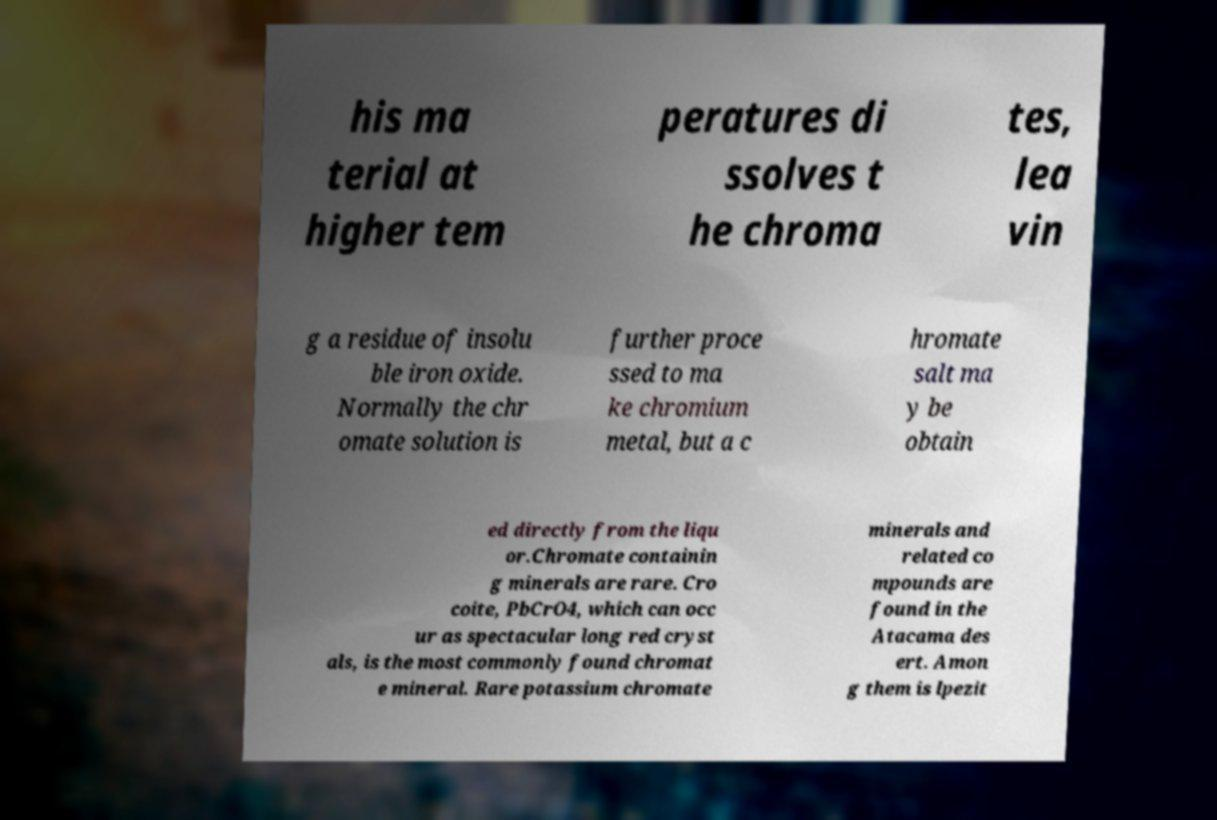For documentation purposes, I need the text within this image transcribed. Could you provide that? his ma terial at higher tem peratures di ssolves t he chroma tes, lea vin g a residue of insolu ble iron oxide. Normally the chr omate solution is further proce ssed to ma ke chromium metal, but a c hromate salt ma y be obtain ed directly from the liqu or.Chromate containin g minerals are rare. Cro coite, PbCrO4, which can occ ur as spectacular long red cryst als, is the most commonly found chromat e mineral. Rare potassium chromate minerals and related co mpounds are found in the Atacama des ert. Amon g them is lpezit 